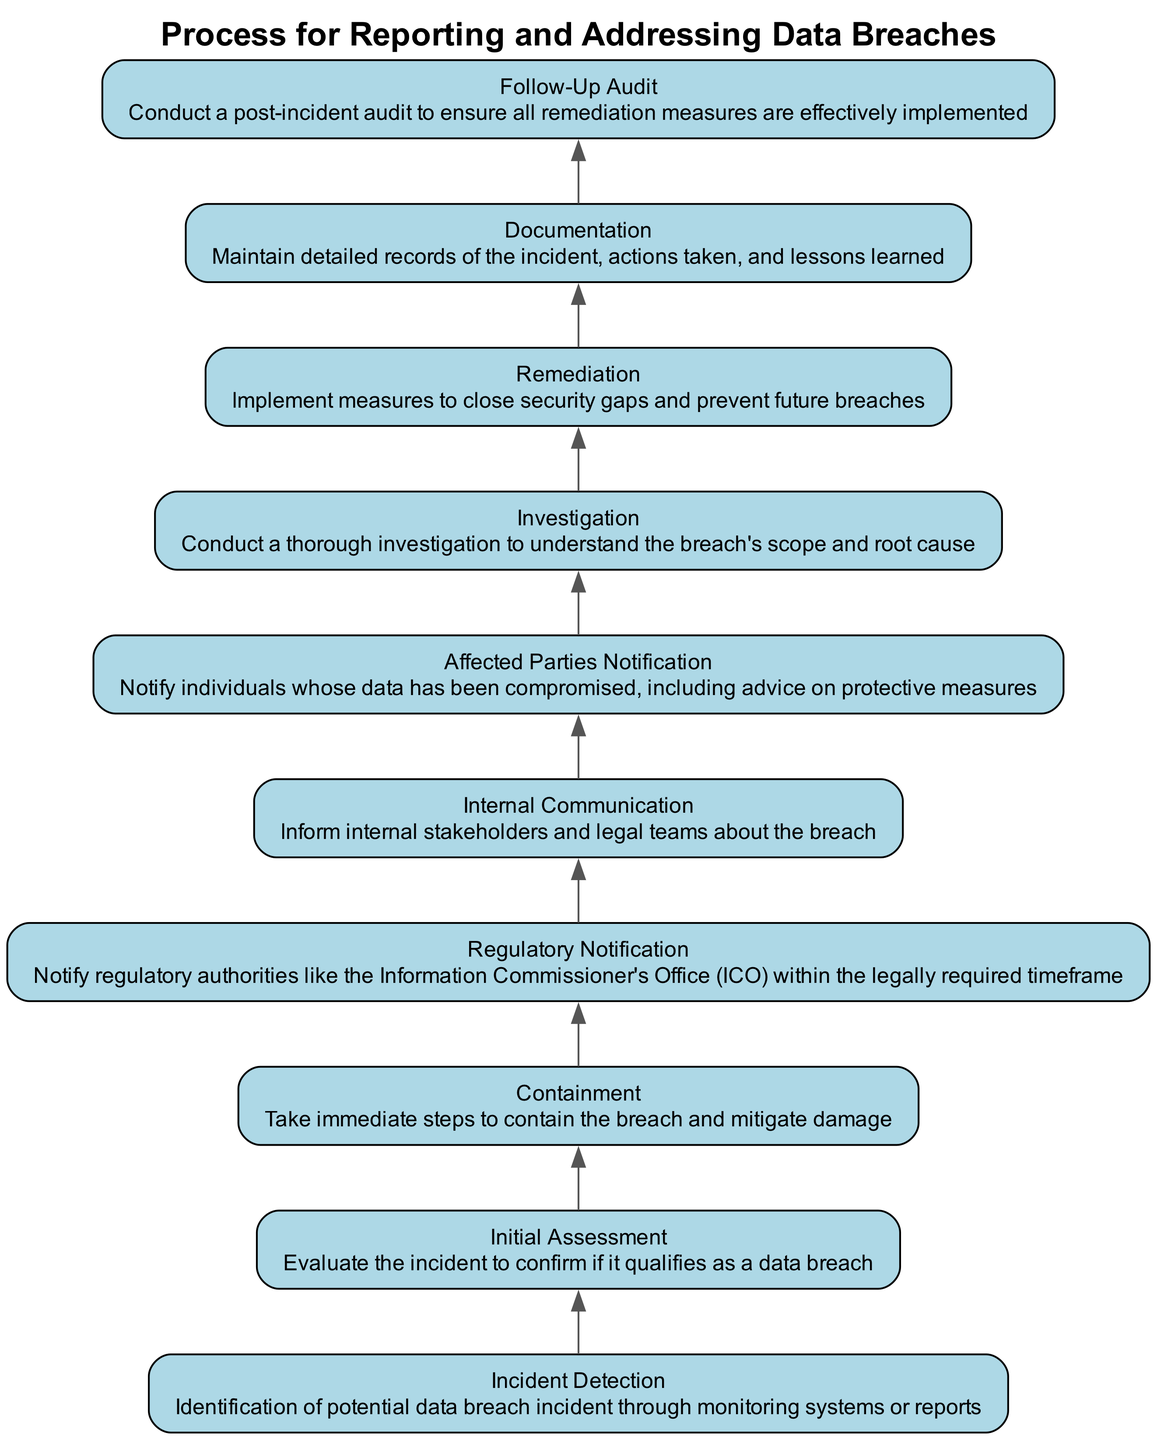What is the first step in the process? The first step is identified by the bottom-most node labeled "Incident Detection". This indicates that incident detection is the starting point of the flow.
Answer: Incident Detection How many total steps are there in the process? By counting the nodes in the diagram, we identify the total steps, which are ten, ranging from "Incident Detection" to "Follow-Up Audit".
Answer: 10 What action must be taken after the "Initial Assessment"? The flow indicates that once the "Initial Assessment" is completed, the next action to be taken is "Containment". This shows the process flow from one step to the next.
Answer: Containment Which step involves notifying regulatory authorities? The step that involves notifying regulatory authorities is specifically labeled "Regulatory Notification". Looking upward in the flow from the low nodes helps to pinpoint this step's function.
Answer: Regulatory Notification What action follows "Investigation"? Following "Investigation", the next action in the diagram is "Remediation". This shows the direct progression as it flows upwards through the process steps.
Answer: Remediation What should happen immediately after detecting an incident? After detecting an incident, the next step is to conduct an "Initial Assessment" to evaluate the incident's validity as a data breach. This step is essential to determine further actions.
Answer: Initial Assessment How is "Affected Parties Notification" related to "Internal Communication"? "Affected Parties Notification" follows directly after "Internal Communication" in the process, indicating that notifying internal stakeholders comes before informing the individuals whose data is compromised.
Answer: Sequential relationship Which two steps are the last actions performed? The last actions in the diagram are "Documentation" and "Follow-Up Audit". These are the concluding parts of the process that ensure all actions and lessons learned are recorded, followed by auditing the effectiveness of solutions applied.
Answer: Documentation and Follow-Up Audit What is the purpose of “Containment”? "Containment" involves taking immediate steps to halt or limit the damage from the breach, which is a critical action after confirming that an incident is a data breach, to prevent further data loss.
Answer: Mitigate damage 